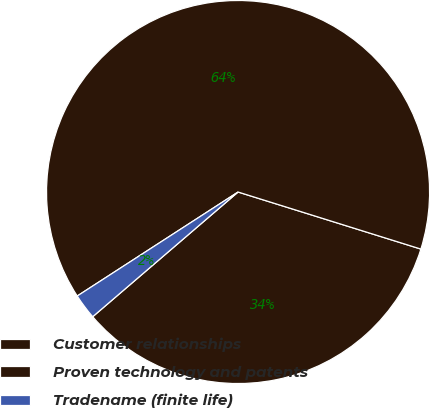Convert chart to OTSL. <chart><loc_0><loc_0><loc_500><loc_500><pie_chart><fcel>Customer relationships<fcel>Proven technology and patents<fcel>Tradename (finite life)<nl><fcel>33.9%<fcel>63.95%<fcel>2.15%<nl></chart> 